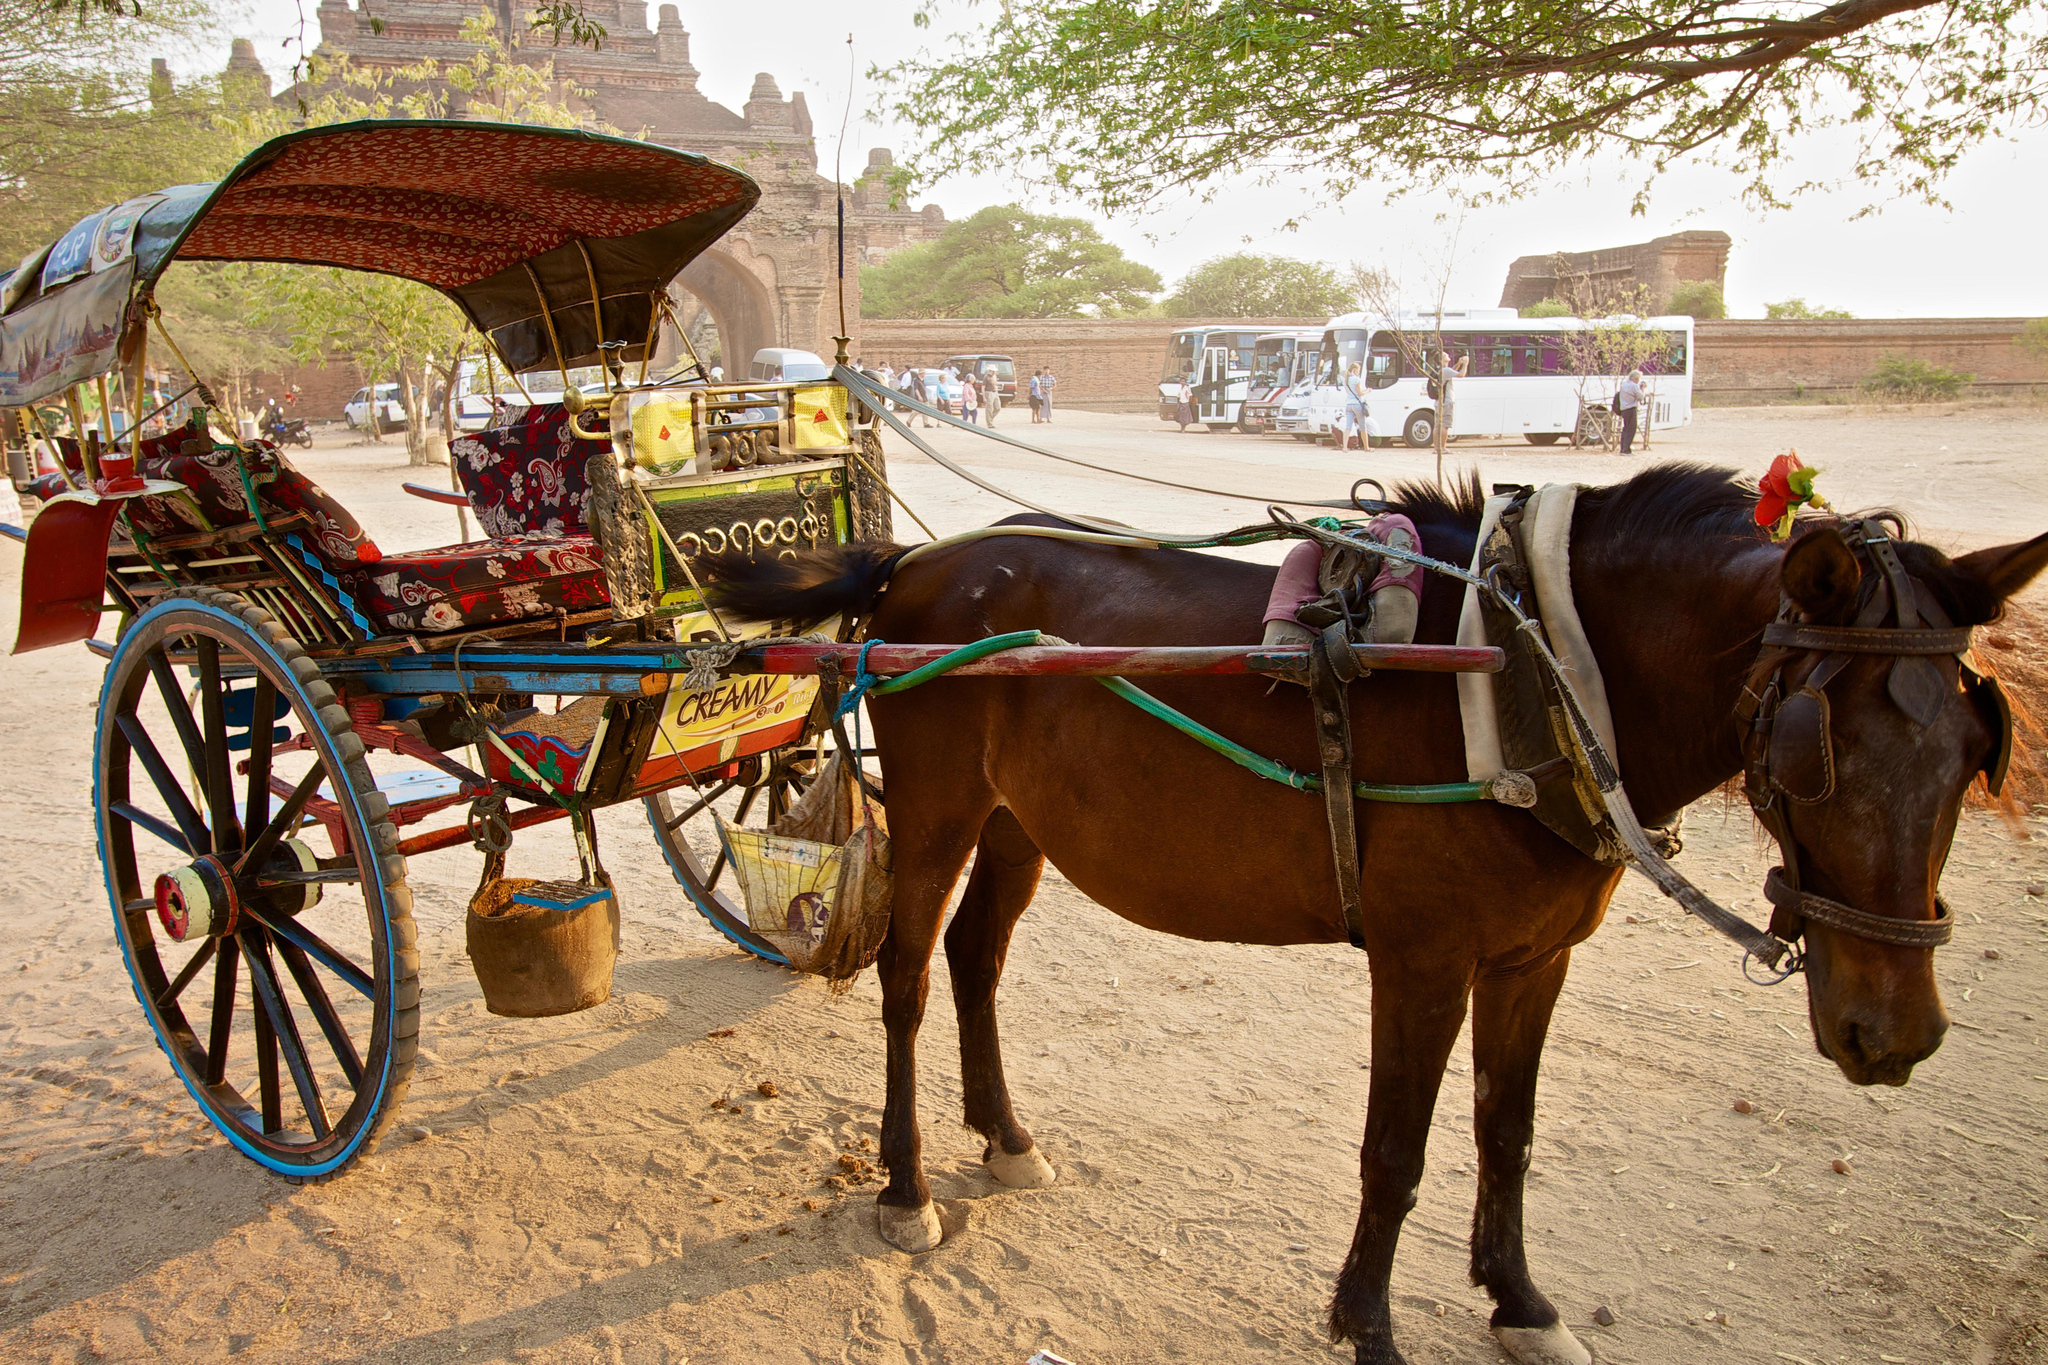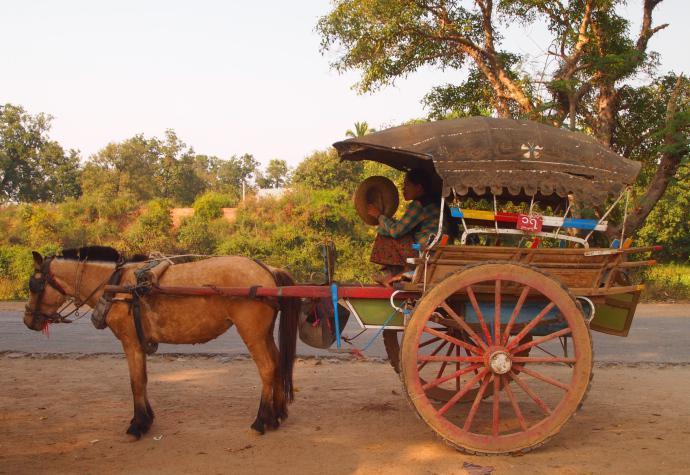The first image is the image on the left, the second image is the image on the right. Given the left and right images, does the statement "Both carts are pulled by brown horses." hold true? Answer yes or no. Yes. 